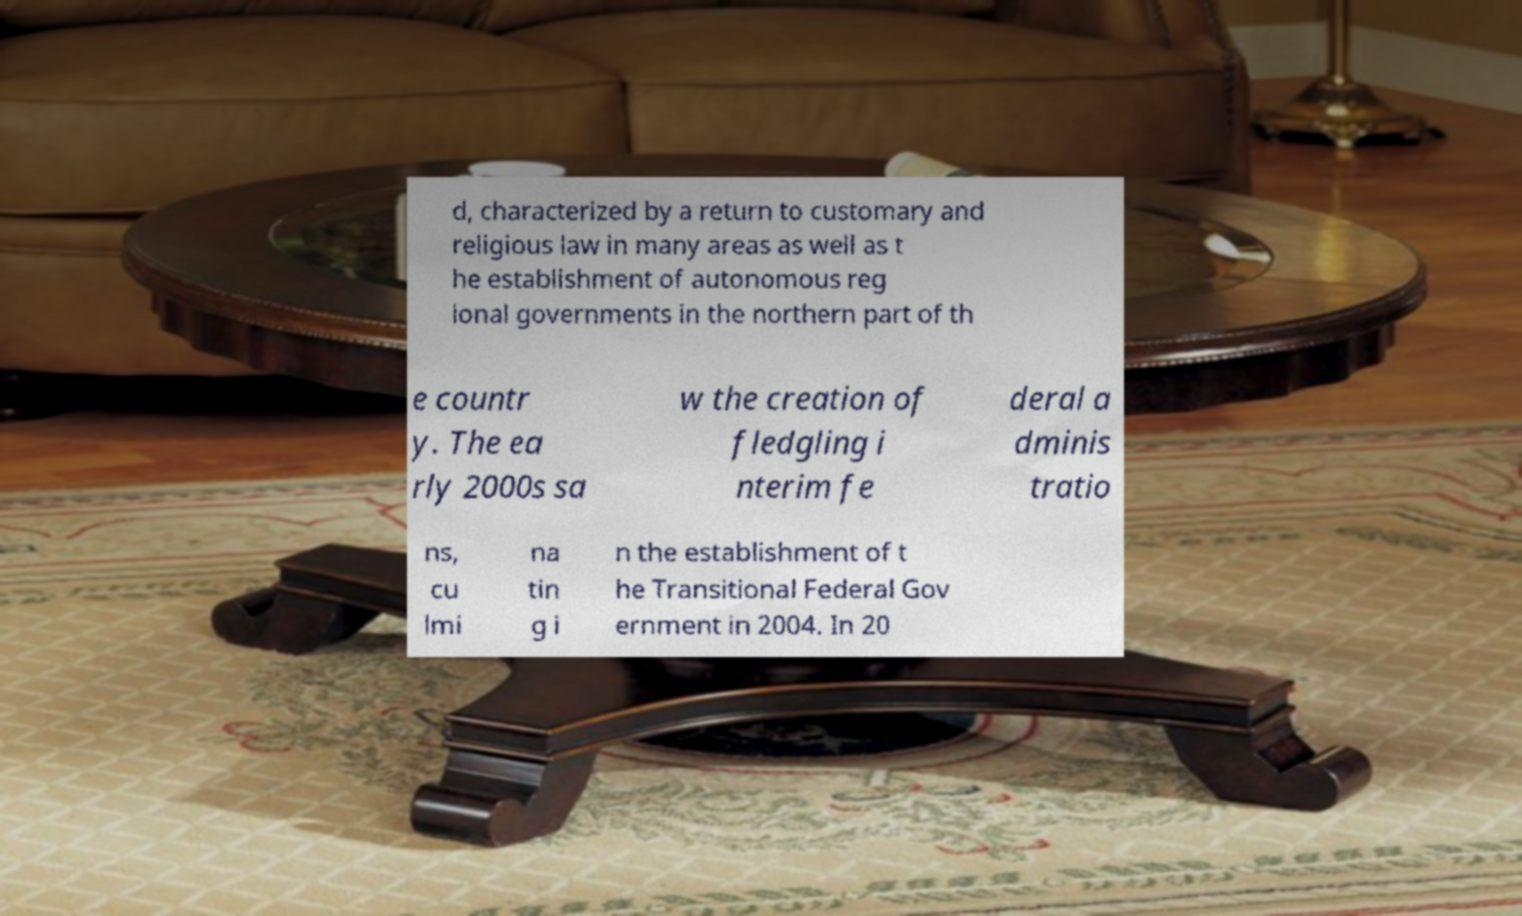There's text embedded in this image that I need extracted. Can you transcribe it verbatim? d, characterized by a return to customary and religious law in many areas as well as t he establishment of autonomous reg ional governments in the northern part of th e countr y. The ea rly 2000s sa w the creation of fledgling i nterim fe deral a dminis tratio ns, cu lmi na tin g i n the establishment of t he Transitional Federal Gov ernment in 2004. In 20 